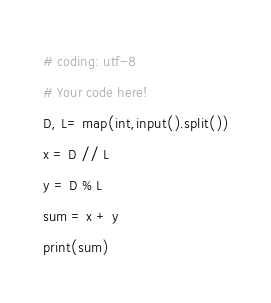<code> <loc_0><loc_0><loc_500><loc_500><_Python_># coding: utf-8
# Your code here!
D, L= map(int,input().split())
x = D // L
y = D % L
sum = x + y
print(sum)

</code> 